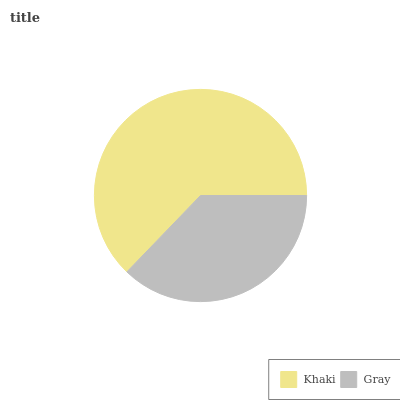Is Gray the minimum?
Answer yes or no. Yes. Is Khaki the maximum?
Answer yes or no. Yes. Is Gray the maximum?
Answer yes or no. No. Is Khaki greater than Gray?
Answer yes or no. Yes. Is Gray less than Khaki?
Answer yes or no. Yes. Is Gray greater than Khaki?
Answer yes or no. No. Is Khaki less than Gray?
Answer yes or no. No. Is Khaki the high median?
Answer yes or no. Yes. Is Gray the low median?
Answer yes or no. Yes. Is Gray the high median?
Answer yes or no. No. Is Khaki the low median?
Answer yes or no. No. 